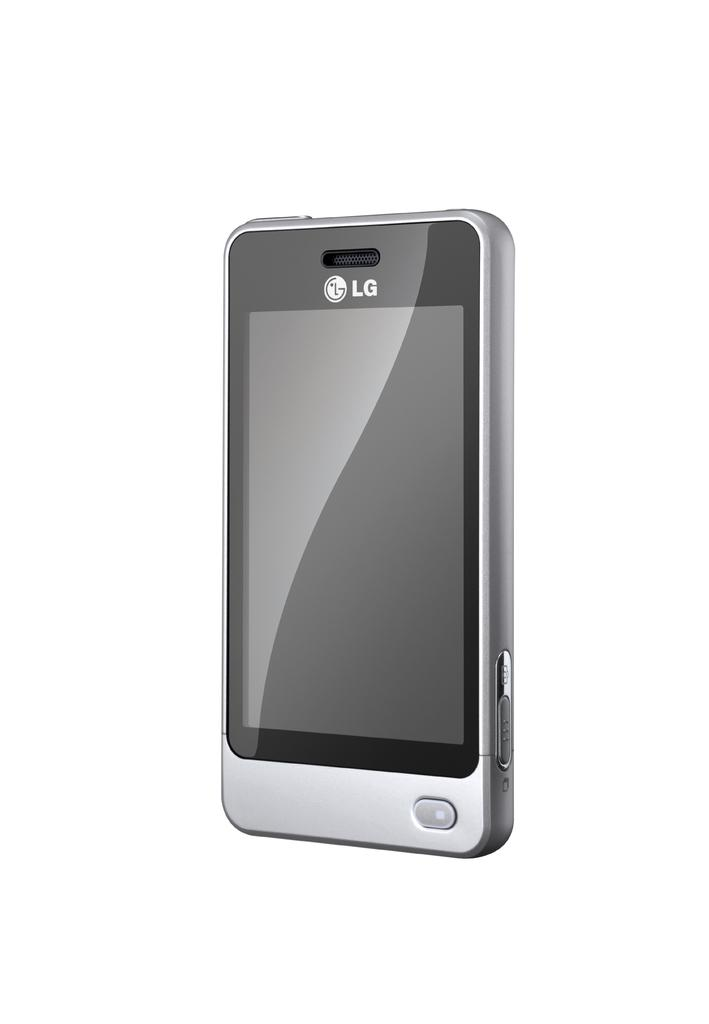<image>
Summarize the visual content of the image. A silver LG smarphone with a single button near the bottom right corner of the bezel. 